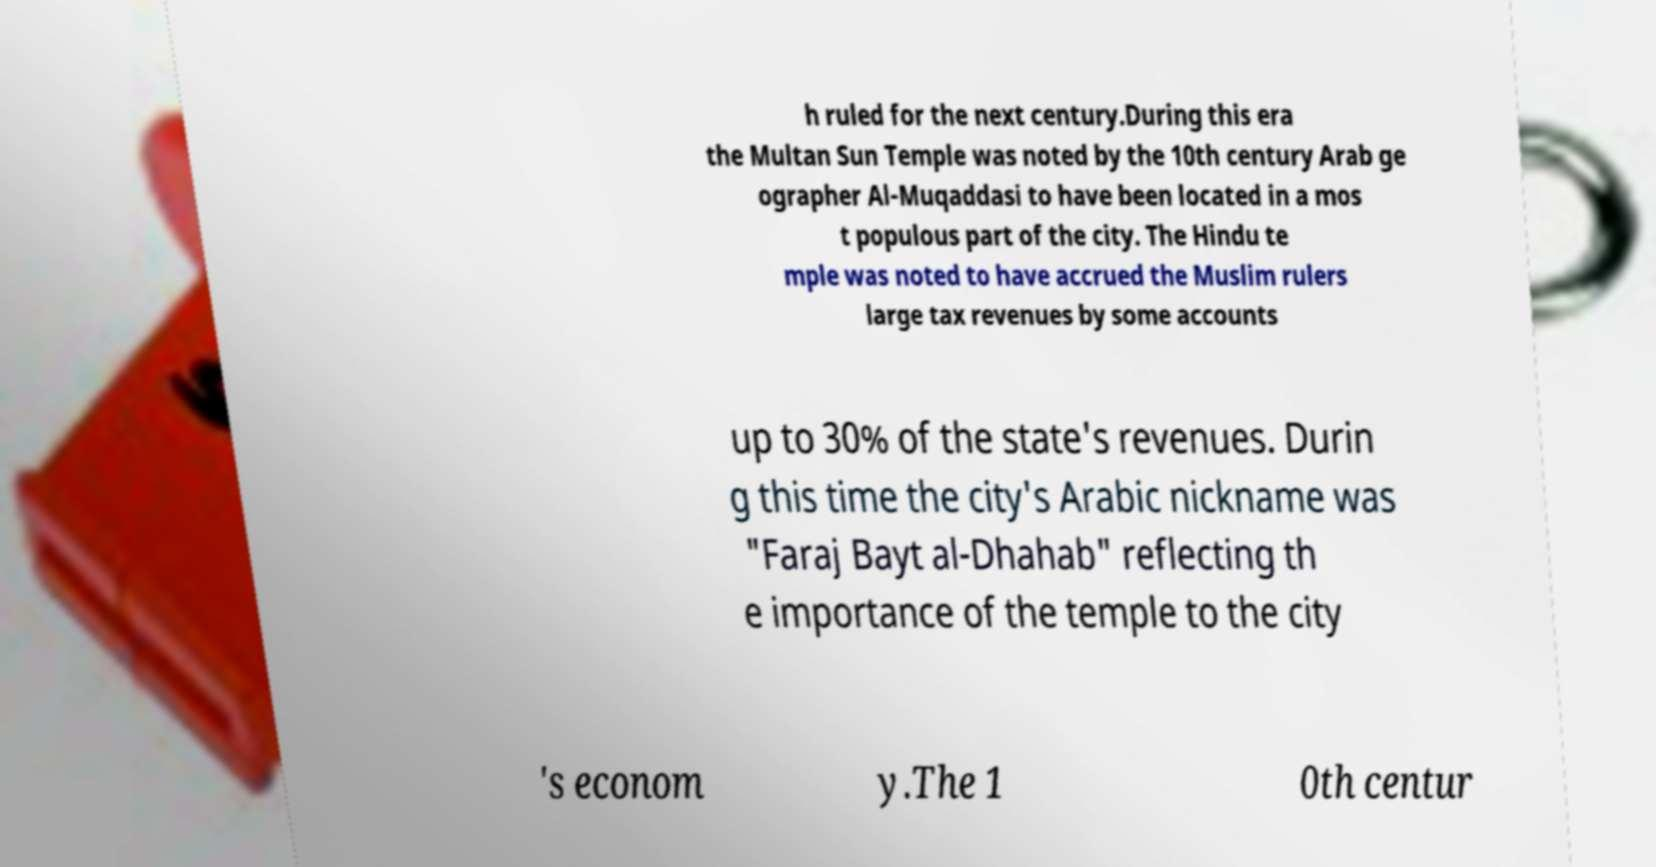Can you accurately transcribe the text from the provided image for me? h ruled for the next century.During this era the Multan Sun Temple was noted by the 10th century Arab ge ographer Al-Muqaddasi to have been located in a mos t populous part of the city. The Hindu te mple was noted to have accrued the Muslim rulers large tax revenues by some accounts up to 30% of the state's revenues. Durin g this time the city's Arabic nickname was "Faraj Bayt al-Dhahab" reflecting th e importance of the temple to the city 's econom y.The 1 0th centur 